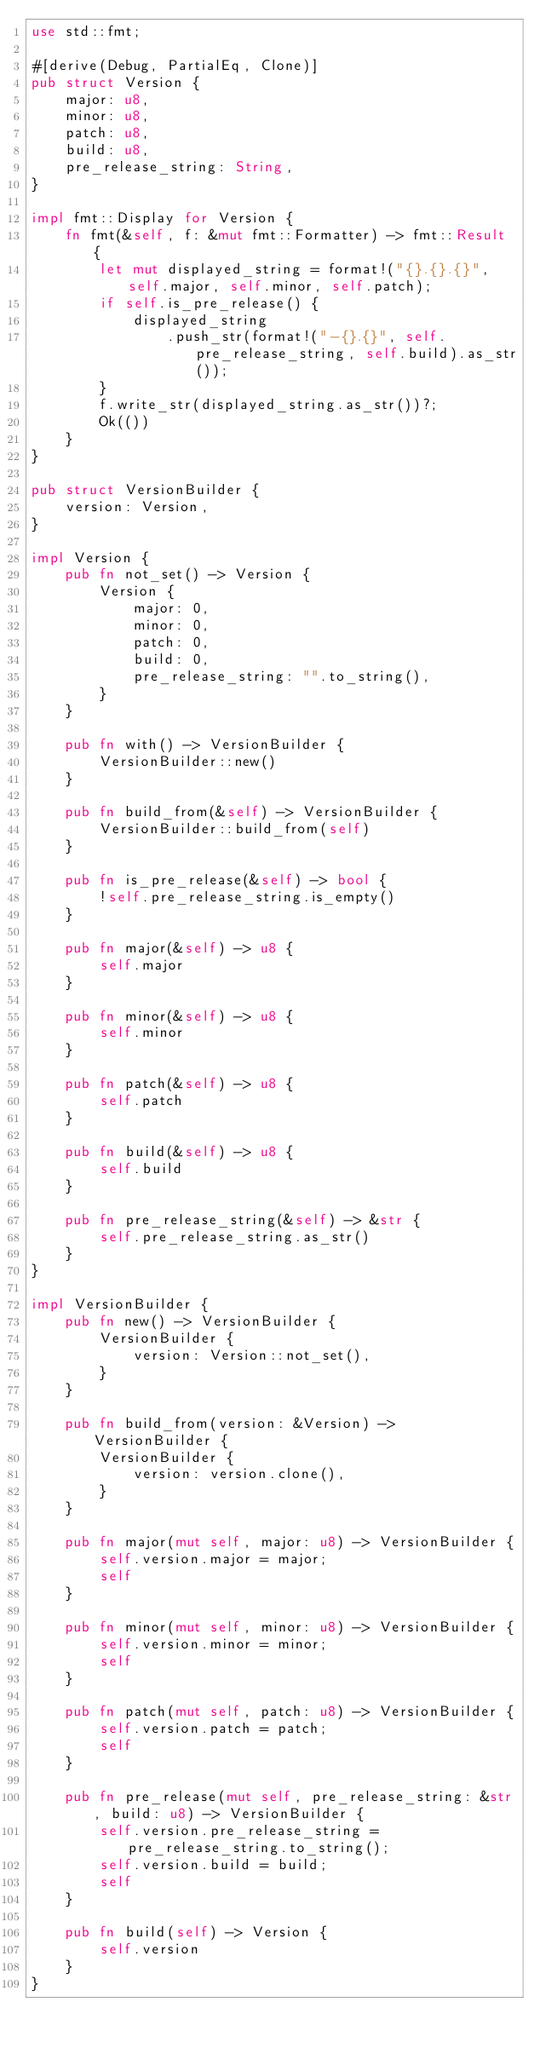<code> <loc_0><loc_0><loc_500><loc_500><_Rust_>use std::fmt;

#[derive(Debug, PartialEq, Clone)]
pub struct Version {
    major: u8,
    minor: u8,
    patch: u8,
    build: u8,
    pre_release_string: String,
}

impl fmt::Display for Version {
    fn fmt(&self, f: &mut fmt::Formatter) -> fmt::Result {
        let mut displayed_string = format!("{}.{}.{}", self.major, self.minor, self.patch);
        if self.is_pre_release() {
            displayed_string
                .push_str(format!("-{}.{}", self.pre_release_string, self.build).as_str());
        }
        f.write_str(displayed_string.as_str())?;
        Ok(())
    }
}

pub struct VersionBuilder {
    version: Version,
}

impl Version {
    pub fn not_set() -> Version {
        Version {
            major: 0,
            minor: 0,
            patch: 0,
            build: 0,
            pre_release_string: "".to_string(),
        }
    }

    pub fn with() -> VersionBuilder {
        VersionBuilder::new()
    }

    pub fn build_from(&self) -> VersionBuilder {
        VersionBuilder::build_from(self)
    }

    pub fn is_pre_release(&self) -> bool {
        !self.pre_release_string.is_empty()
    }

    pub fn major(&self) -> u8 {
        self.major
    }

    pub fn minor(&self) -> u8 {
        self.minor
    }

    pub fn patch(&self) -> u8 {
        self.patch
    }

    pub fn build(&self) -> u8 {
        self.build
    }

    pub fn pre_release_string(&self) -> &str {
        self.pre_release_string.as_str()
    }
}

impl VersionBuilder {
    pub fn new() -> VersionBuilder {
        VersionBuilder {
            version: Version::not_set(),
        }
    }

    pub fn build_from(version: &Version) -> VersionBuilder {
        VersionBuilder {
            version: version.clone(),
        }
    }

    pub fn major(mut self, major: u8) -> VersionBuilder {
        self.version.major = major;
        self
    }

    pub fn minor(mut self, minor: u8) -> VersionBuilder {
        self.version.minor = minor;
        self
    }

    pub fn patch(mut self, patch: u8) -> VersionBuilder {
        self.version.patch = patch;
        self
    }

    pub fn pre_release(mut self, pre_release_string: &str, build: u8) -> VersionBuilder {
        self.version.pre_release_string = pre_release_string.to_string();
        self.version.build = build;
        self
    }

    pub fn build(self) -> Version {
        self.version
    }
}
</code> 